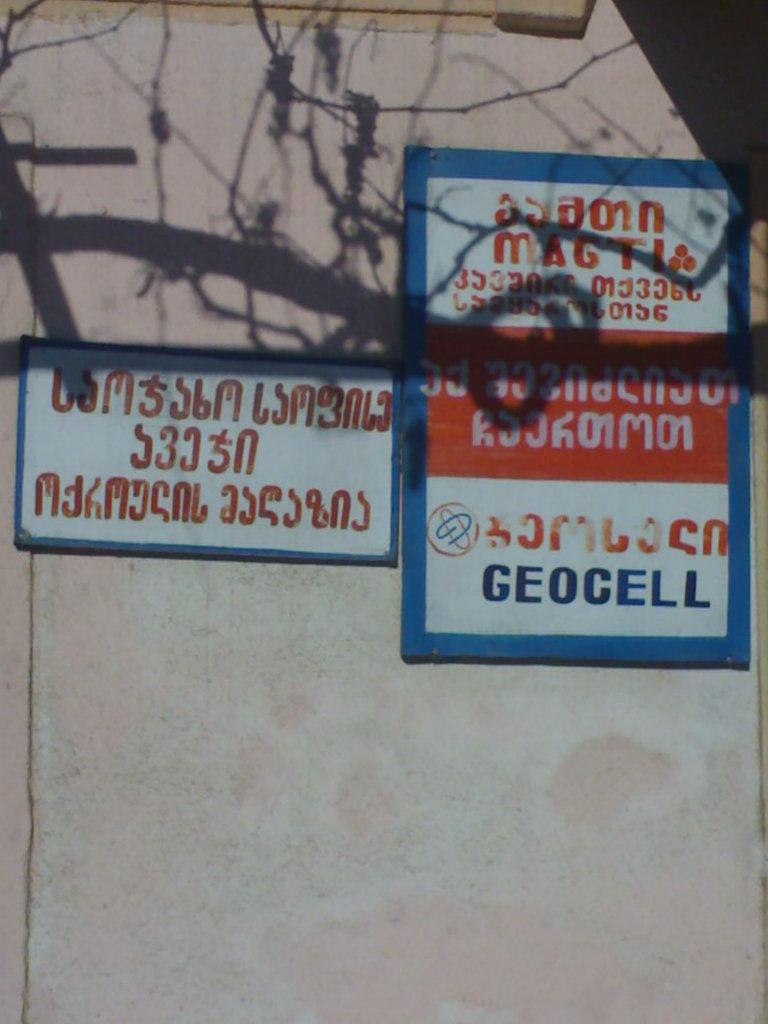<image>
Present a compact description of the photo's key features. a large sign for geocell and a small sign beside it. 